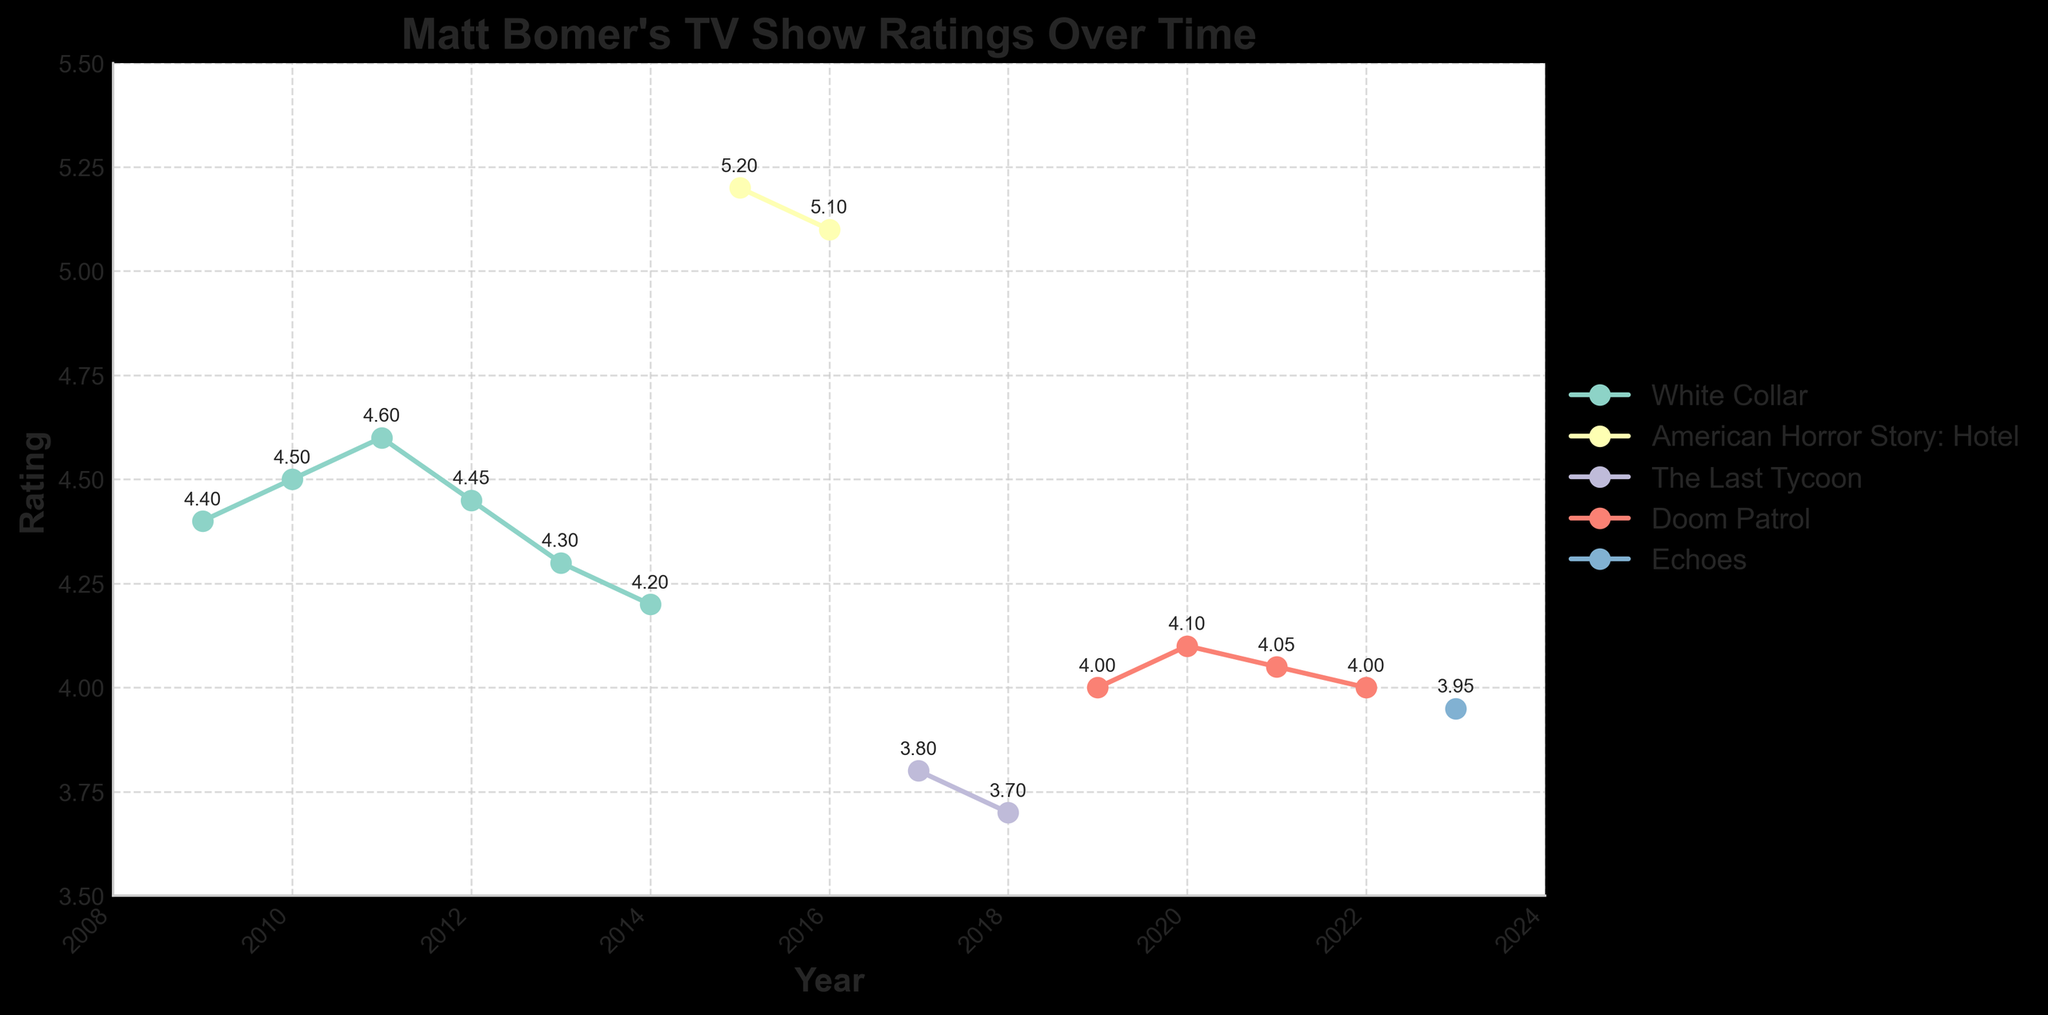what's the title of the plot? The title of the plot is displayed at the top center in a larger and bold font. By looking at the top of the figure, you can see the title "Matt Bomer's TV Show Ratings Over Time".
Answer: Matt Bomer's TV Show Ratings Over Time how many TV shows are represented in the plot? Each TV show is represented by a different line, and by looking at the legend on the right side of the plot, you can count the number of unique shows listed. There are four in total.
Answer: Four which TV show had the highest rating and in which year? By looking at the highest point on the y-axis and following the corresponding line, you can see that "American Horror Story: Hotel" had the highest rating in 2015.
Answer: American Horror Story: Hotel, 2015 compare the rating trend of "White Collar" and "Doom Patrol" between 2010 and 2020. From the plot, the ratings for "White Collar" gradually decreased from 2010 to 2014, while "Doom Patrol" maintained relatively stable ratings with slight fluctuations between 2019 and 2020.
Answer: "White Collar" decreased, "Doom Patrol" stable what is the average rating of "Doom Patrol" from 2019 to 2022? To calculate the average rating, sum the ratings from 2019, 2020, 2021, and 2022 and divide by 4: (4.00 + 4.10 + 4.05 + 4.00)/4 = 4.0375.
Answer: 4.04 which TV show experienced the biggest drop in ratings, and how much did it drop? By comparing the steepest declines in the plot, "The Last Tycoon" experienced the largest drop from 2017 to 2018, decreasing from 3.80 to 3.70. The difference is 3.80 - 3.70 = 0.10.
Answer: The Last Tycoon, 0.10 between "Echoes" and "The Last Tycoon," which had a higher rating in 2023? By looking at the plot for the year 2023, you can see that "Echoes" has a rating of 3.95, compared to the last rating of "The Last Tycoon" which was 3.70 in 2018.
Answer: Echoes which two years had the same rating for the same show? By examining where the points overlap on the same line, "Doom Patrol" had the same rating of 4.00 in both 2019 and 2022.
Answer: 2019 and 2022 how does the rating of "American Horror Story: Hotel" change between 2015 to 2016? From the plot, we can see that "American Horror Story: Hotel" had a slight decrease in ratings from 5.20 in 2015 to 5.10 in 2016.
Answer: Decrease from 5.20 to 5.10 